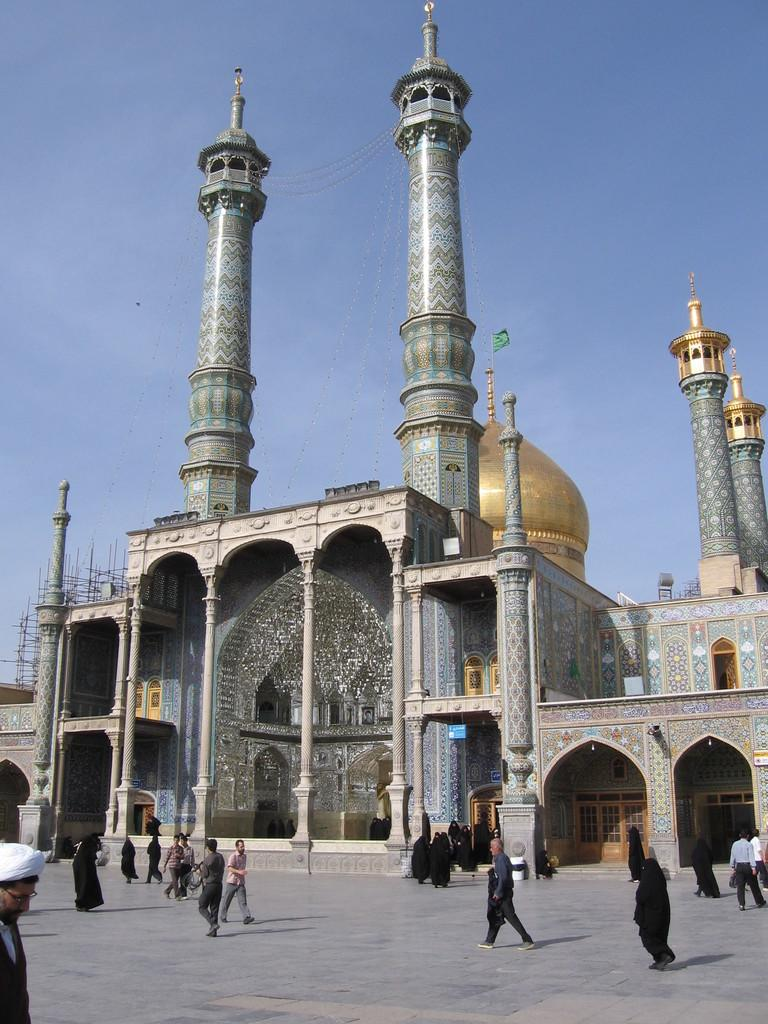What type of location is depicted in the image? The image depicts a sacred place. Where is this sacred place located? The sacred place is located in Iran. What religious group considers this place significant? Shia-Muslims consider this place significant. What type of alley can be seen in the image? There is no alley present in the image; it depicts a sacred place in Iran. 